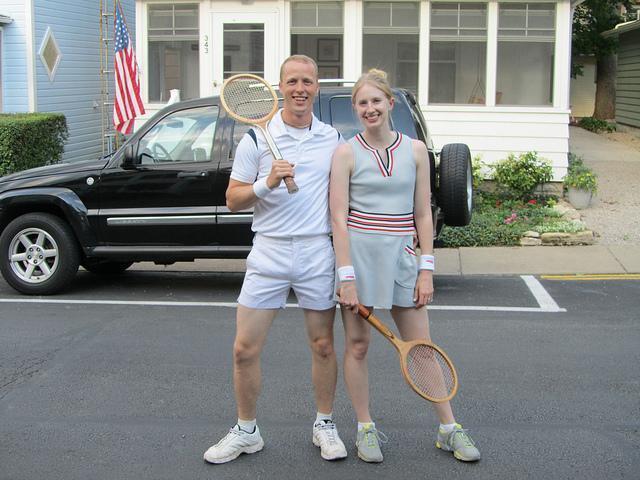How many people are there?
Give a very brief answer. 2. How many tennis rackets are there?
Give a very brief answer. 2. How many of the dogs have black spots?
Give a very brief answer. 0. 